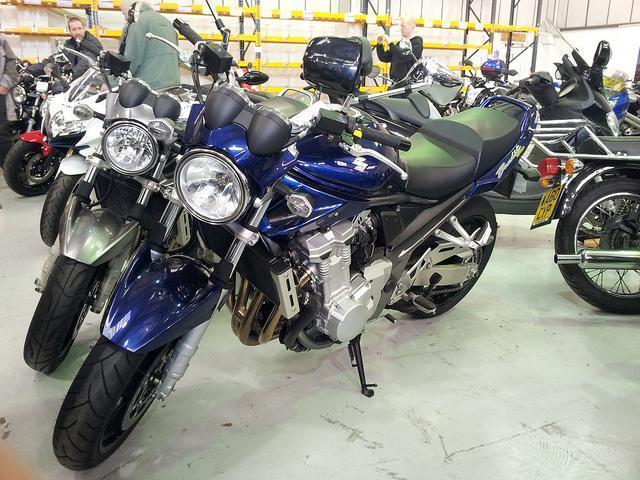How many motorcycles are there?
Give a very brief answer. 7. How many umbrellas are in the photo?
Give a very brief answer. 0. 